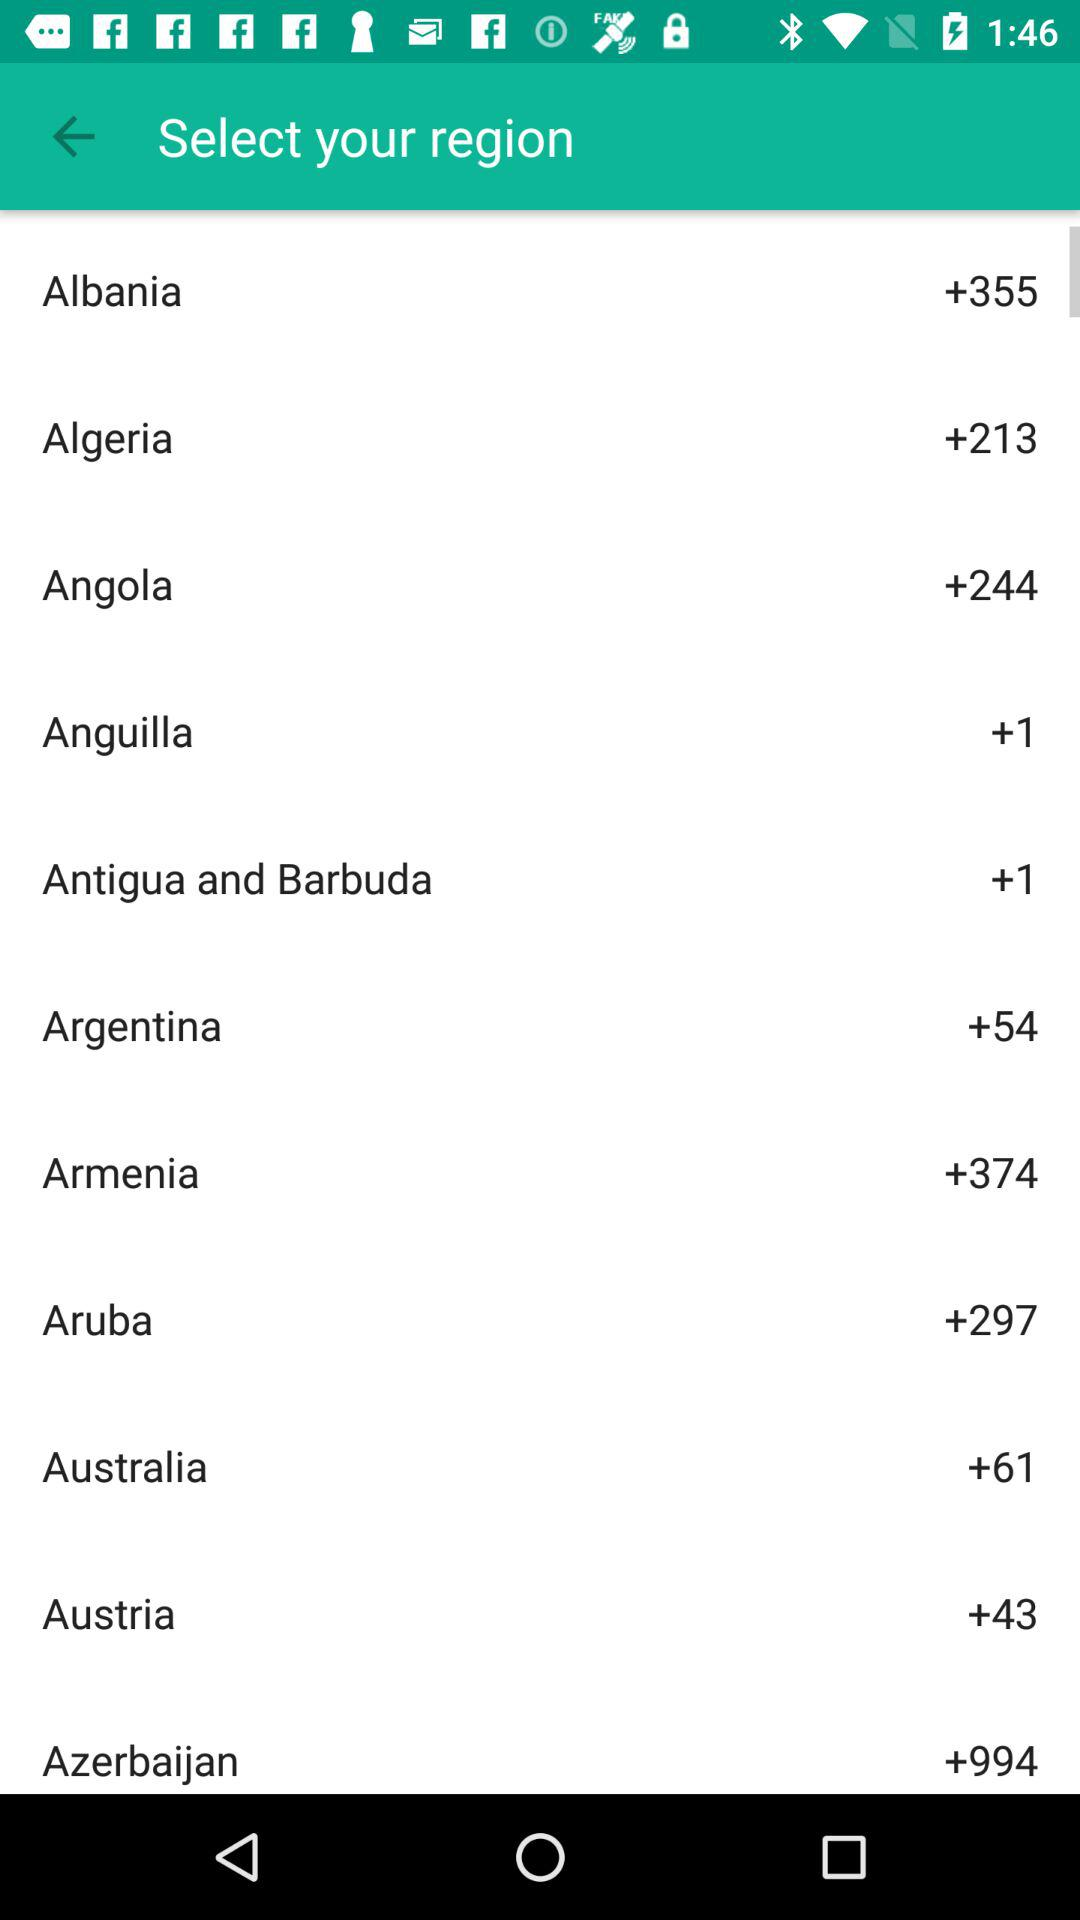How many countries have a +355 phone code?
Answer the question using a single word or phrase. 1 